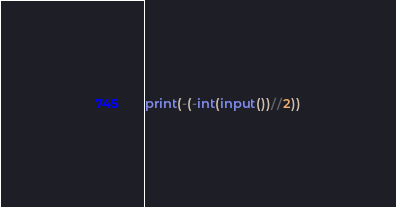Convert code to text. <code><loc_0><loc_0><loc_500><loc_500><_Python_>print(-(-int(input())//2))</code> 